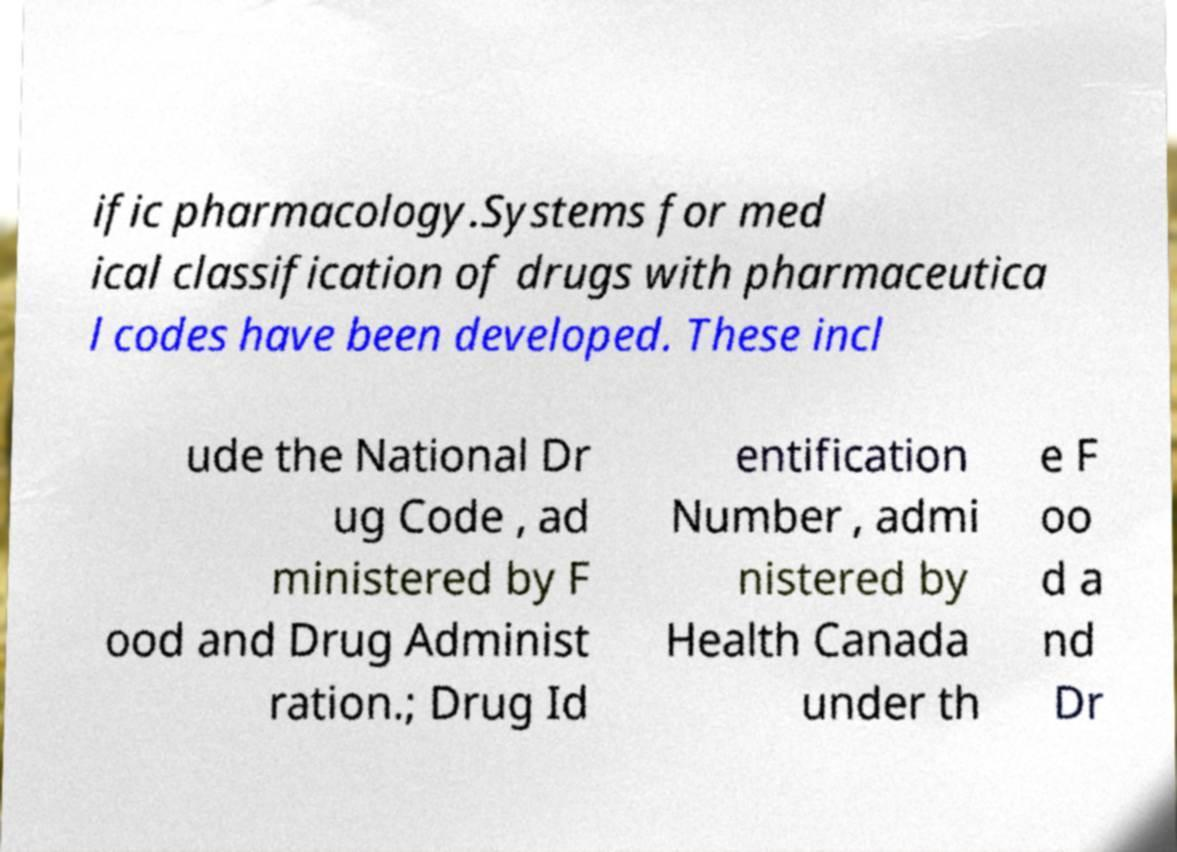What messages or text are displayed in this image? I need them in a readable, typed format. ific pharmacology.Systems for med ical classification of drugs with pharmaceutica l codes have been developed. These incl ude the National Dr ug Code , ad ministered by F ood and Drug Administ ration.; Drug Id entification Number , admi nistered by Health Canada under th e F oo d a nd Dr 